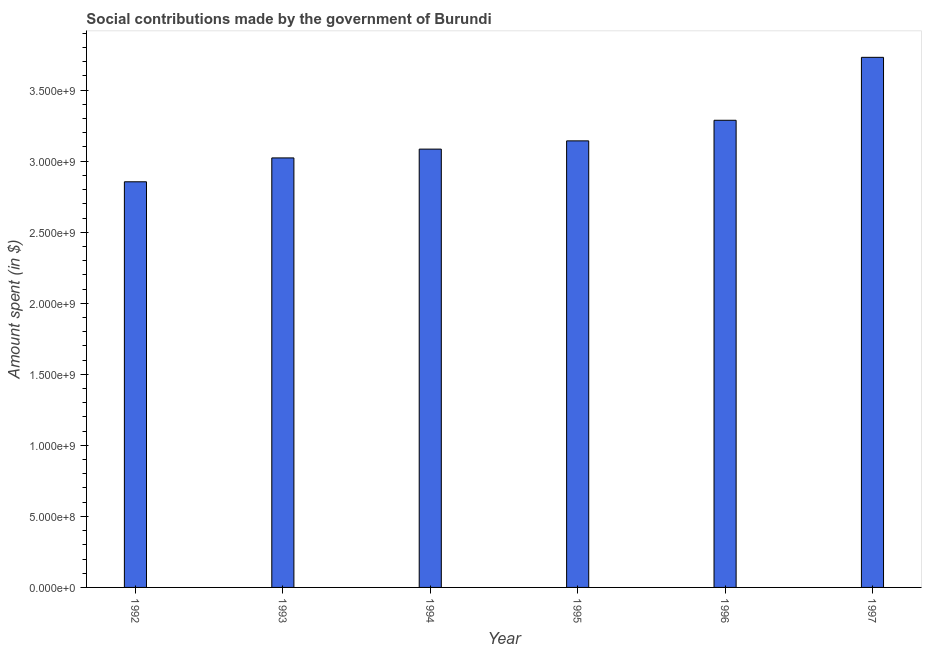Does the graph contain any zero values?
Offer a very short reply. No. Does the graph contain grids?
Keep it short and to the point. No. What is the title of the graph?
Keep it short and to the point. Social contributions made by the government of Burundi. What is the label or title of the Y-axis?
Ensure brevity in your answer.  Amount spent (in $). What is the amount spent in making social contributions in 1994?
Provide a succinct answer. 3.08e+09. Across all years, what is the maximum amount spent in making social contributions?
Provide a short and direct response. 3.73e+09. Across all years, what is the minimum amount spent in making social contributions?
Your response must be concise. 2.86e+09. In which year was the amount spent in making social contributions maximum?
Keep it short and to the point. 1997. In which year was the amount spent in making social contributions minimum?
Provide a short and direct response. 1992. What is the sum of the amount spent in making social contributions?
Make the answer very short. 1.91e+1. What is the difference between the amount spent in making social contributions in 1994 and 1995?
Offer a terse response. -5.80e+07. What is the average amount spent in making social contributions per year?
Your answer should be very brief. 3.19e+09. What is the median amount spent in making social contributions?
Offer a very short reply. 3.11e+09. In how many years, is the amount spent in making social contributions greater than 3700000000 $?
Offer a very short reply. 1. Do a majority of the years between 1993 and 1994 (inclusive) have amount spent in making social contributions greater than 2300000000 $?
Offer a very short reply. Yes. What is the ratio of the amount spent in making social contributions in 1994 to that in 1997?
Provide a succinct answer. 0.83. Is the amount spent in making social contributions in 1994 less than that in 1995?
Provide a succinct answer. Yes. Is the difference between the amount spent in making social contributions in 1994 and 1995 greater than the difference between any two years?
Provide a succinct answer. No. What is the difference between the highest and the second highest amount spent in making social contributions?
Offer a terse response. 4.43e+08. Is the sum of the amount spent in making social contributions in 1996 and 1997 greater than the maximum amount spent in making social contributions across all years?
Your answer should be compact. Yes. What is the difference between the highest and the lowest amount spent in making social contributions?
Provide a short and direct response. 8.76e+08. In how many years, is the amount spent in making social contributions greater than the average amount spent in making social contributions taken over all years?
Provide a succinct answer. 2. Are all the bars in the graph horizontal?
Offer a very short reply. No. How many years are there in the graph?
Keep it short and to the point. 6. What is the Amount spent (in $) of 1992?
Your response must be concise. 2.86e+09. What is the Amount spent (in $) of 1993?
Keep it short and to the point. 3.02e+09. What is the Amount spent (in $) in 1994?
Ensure brevity in your answer.  3.08e+09. What is the Amount spent (in $) of 1995?
Your response must be concise. 3.14e+09. What is the Amount spent (in $) in 1996?
Your response must be concise. 3.29e+09. What is the Amount spent (in $) in 1997?
Provide a short and direct response. 3.73e+09. What is the difference between the Amount spent (in $) in 1992 and 1993?
Provide a succinct answer. -1.68e+08. What is the difference between the Amount spent (in $) in 1992 and 1994?
Ensure brevity in your answer.  -2.30e+08. What is the difference between the Amount spent (in $) in 1992 and 1995?
Your answer should be compact. -2.88e+08. What is the difference between the Amount spent (in $) in 1992 and 1996?
Give a very brief answer. -4.33e+08. What is the difference between the Amount spent (in $) in 1992 and 1997?
Your answer should be compact. -8.76e+08. What is the difference between the Amount spent (in $) in 1993 and 1994?
Give a very brief answer. -6.20e+07. What is the difference between the Amount spent (in $) in 1993 and 1995?
Offer a terse response. -1.20e+08. What is the difference between the Amount spent (in $) in 1993 and 1996?
Make the answer very short. -2.65e+08. What is the difference between the Amount spent (in $) in 1993 and 1997?
Your answer should be compact. -7.08e+08. What is the difference between the Amount spent (in $) in 1994 and 1995?
Your answer should be compact. -5.80e+07. What is the difference between the Amount spent (in $) in 1994 and 1996?
Make the answer very short. -2.03e+08. What is the difference between the Amount spent (in $) in 1994 and 1997?
Your response must be concise. -6.46e+08. What is the difference between the Amount spent (in $) in 1995 and 1996?
Keep it short and to the point. -1.45e+08. What is the difference between the Amount spent (in $) in 1995 and 1997?
Keep it short and to the point. -5.88e+08. What is the difference between the Amount spent (in $) in 1996 and 1997?
Your answer should be very brief. -4.43e+08. What is the ratio of the Amount spent (in $) in 1992 to that in 1993?
Provide a short and direct response. 0.94. What is the ratio of the Amount spent (in $) in 1992 to that in 1994?
Your response must be concise. 0.93. What is the ratio of the Amount spent (in $) in 1992 to that in 1995?
Ensure brevity in your answer.  0.91. What is the ratio of the Amount spent (in $) in 1992 to that in 1996?
Provide a short and direct response. 0.87. What is the ratio of the Amount spent (in $) in 1992 to that in 1997?
Your response must be concise. 0.77. What is the ratio of the Amount spent (in $) in 1993 to that in 1994?
Offer a very short reply. 0.98. What is the ratio of the Amount spent (in $) in 1993 to that in 1995?
Ensure brevity in your answer.  0.96. What is the ratio of the Amount spent (in $) in 1993 to that in 1996?
Give a very brief answer. 0.92. What is the ratio of the Amount spent (in $) in 1993 to that in 1997?
Make the answer very short. 0.81. What is the ratio of the Amount spent (in $) in 1994 to that in 1995?
Your answer should be compact. 0.98. What is the ratio of the Amount spent (in $) in 1994 to that in 1996?
Keep it short and to the point. 0.94. What is the ratio of the Amount spent (in $) in 1994 to that in 1997?
Offer a terse response. 0.83. What is the ratio of the Amount spent (in $) in 1995 to that in 1996?
Your response must be concise. 0.96. What is the ratio of the Amount spent (in $) in 1995 to that in 1997?
Your answer should be very brief. 0.84. What is the ratio of the Amount spent (in $) in 1996 to that in 1997?
Offer a very short reply. 0.88. 